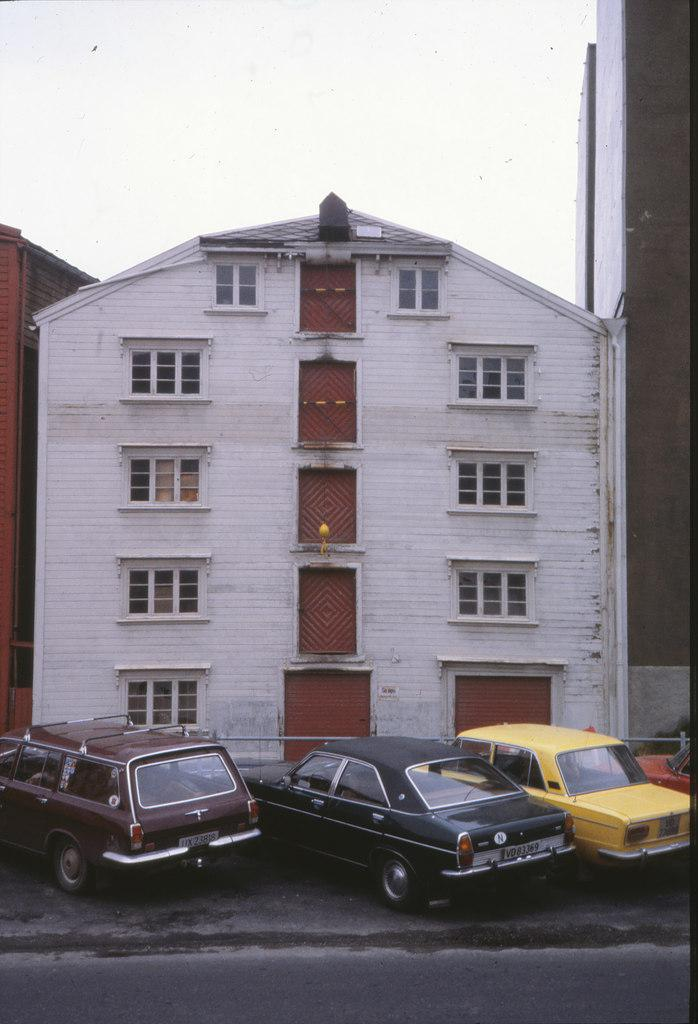What type of surface is visible in the image? There is ground visible in the image. What can be seen on the ground in the image? There are vehicles on the ground in the image. What structures are present in the image? There are buildings in the image. What is visible in the background of the image? The sky is visible in the background of the image. What type of zinc is used to construct the buildings in the image? There is no information about the type of zinc used in the construction of the buildings in the image. What month is depicted in the image? The image does not depict a specific month; it only shows the ground, vehicles, buildings, and sky. 